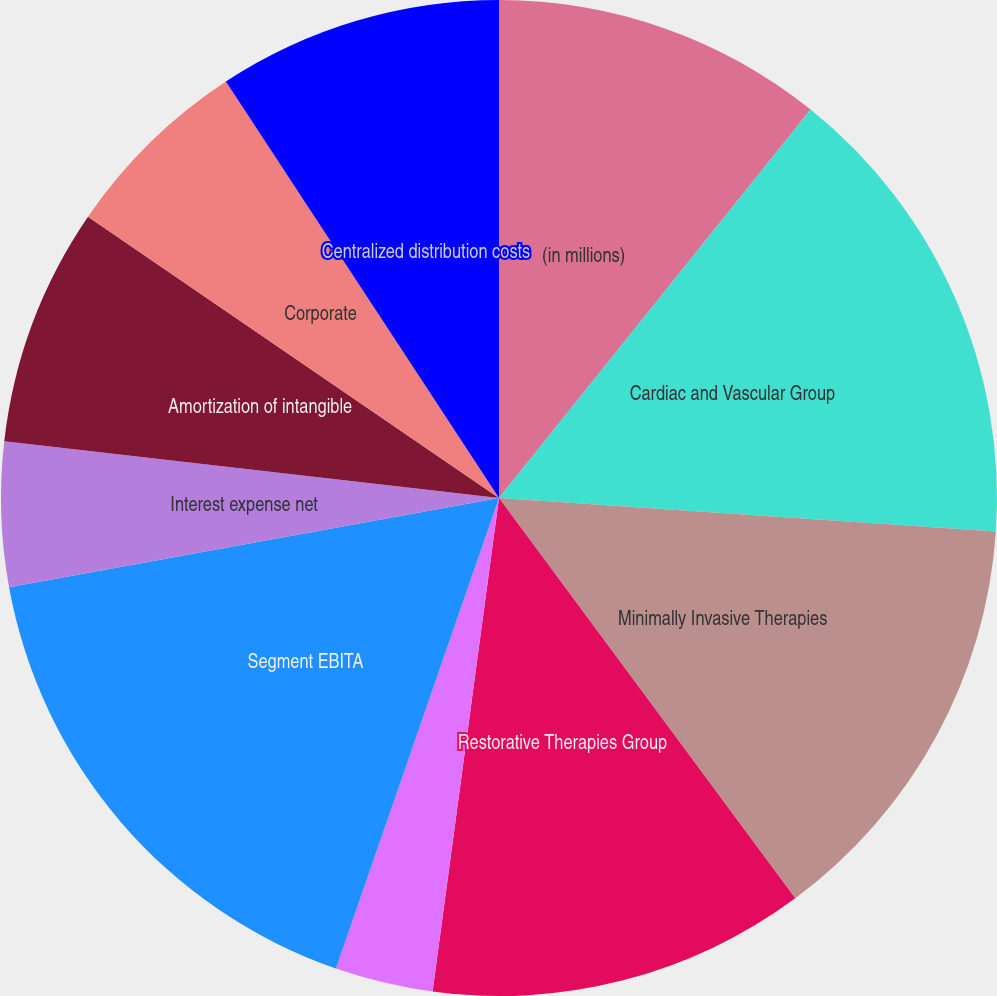<chart> <loc_0><loc_0><loc_500><loc_500><pie_chart><fcel>(in millions)<fcel>Cardiac and Vascular Group<fcel>Minimally Invasive Therapies<fcel>Restorative Therapies Group<fcel>Diabetes Group<fcel>Segment EBITA<fcel>Interest expense net<fcel>Amortization of intangible<fcel>Corporate<fcel>Centralized distribution costs<nl><fcel>10.76%<fcel>15.31%<fcel>13.79%<fcel>12.27%<fcel>3.18%<fcel>16.82%<fcel>4.69%<fcel>7.73%<fcel>6.21%<fcel>9.24%<nl></chart> 